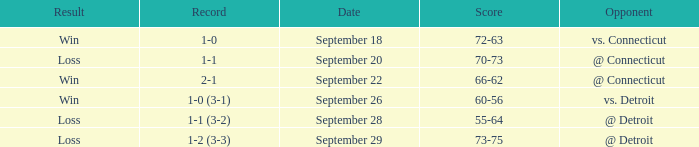WHAT IS THE OPPONENT WITH A SCORE OF 72-63? Vs. connecticut. 